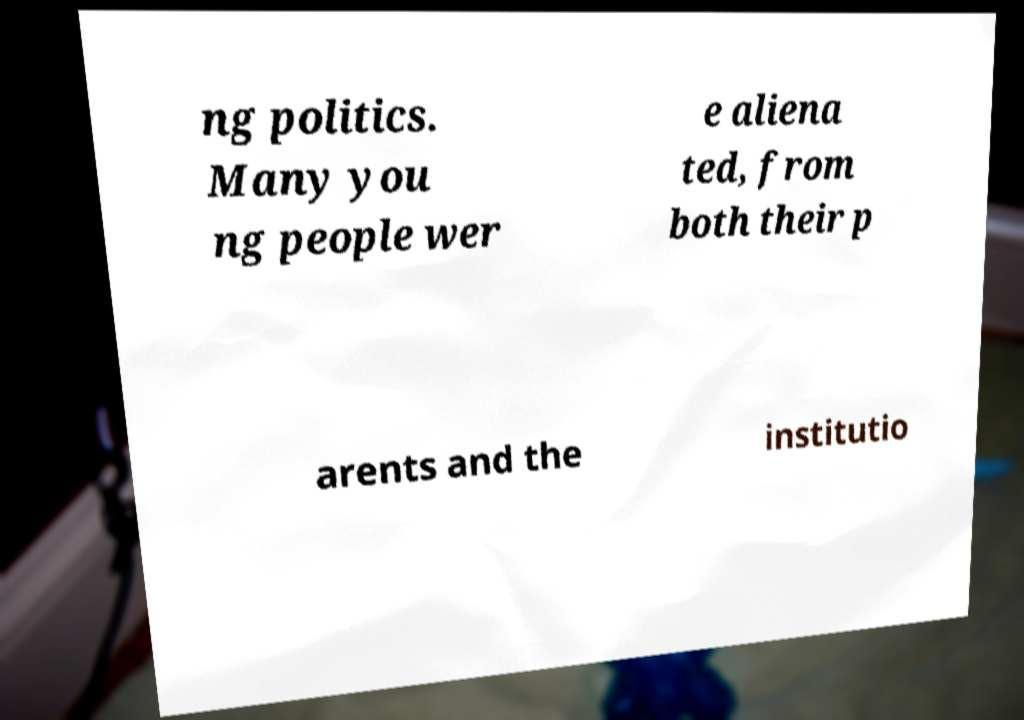Please read and relay the text visible in this image. What does it say? ng politics. Many you ng people wer e aliena ted, from both their p arents and the institutio 